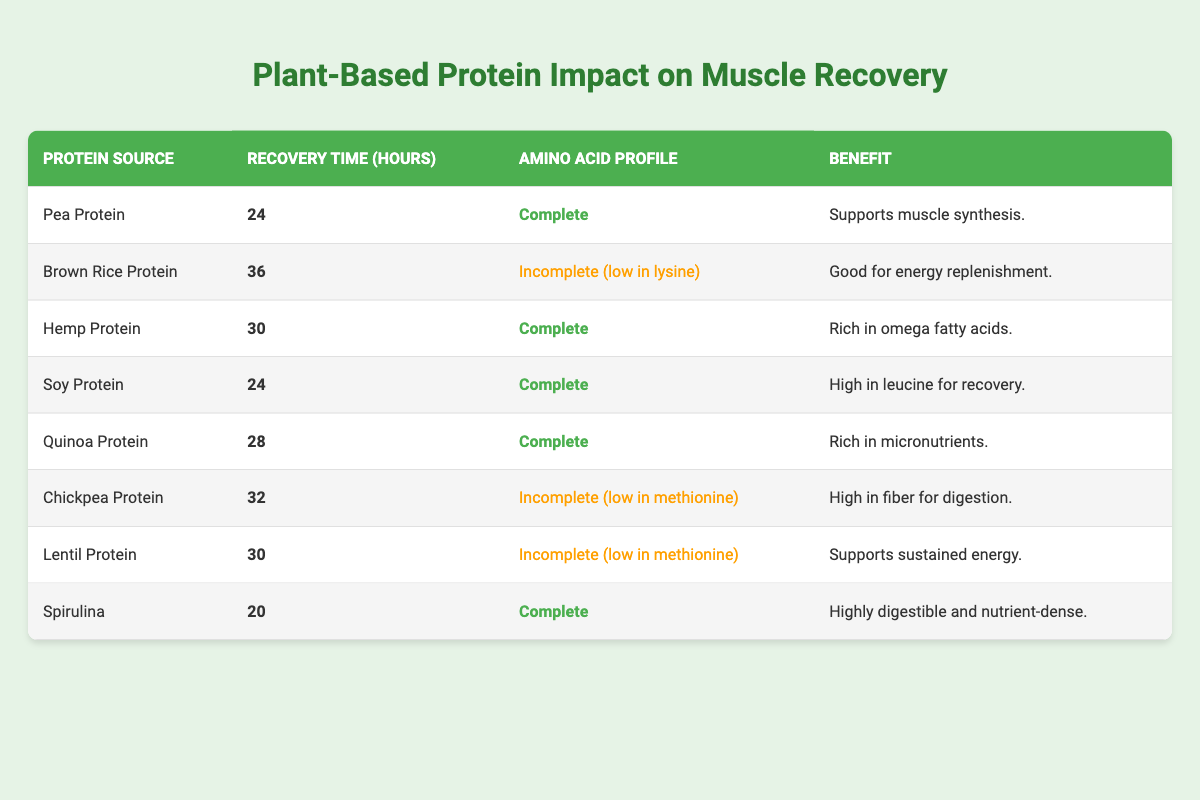What is the muscle recovery time for Pea Protein? The table shows that Pea Protein has a muscle recovery time of 24 hours.
Answer: 24 hours Which plant-based protein source has the highest muscle recovery time? The table lists Brown Rice Protein as having the highest muscle recovery time of 36 hours compared to the other sources.
Answer: Brown Rice Protein Is Spirulina's amino acid profile complete? Yes, according to the table, Spirulina has a complete amino acid profile.
Answer: Yes How many protein sources have a recovery time of 30 hours or more? The sources with 30 hours or more are Brown Rice Protein (36), Chickpea Protein (32), and Lentil Protein (30). Thus, there are 3 sources.
Answer: 3 What is the average muscle recovery time of all listed plant-based protein sources? Adding the recovery times: 24 + 36 + 30 + 24 + 28 + 32 + 30 + 20 =  224. There are 8 sources, so the average is 224/8 = 28 hours.
Answer: 28 hours Does any protein source have a muscle recovery time less than 25 hours? Yes, Pea Protein (24) and Spirulina (20) both have recovery times less than 25 hours.
Answer: Yes Which protein sources have an incomplete amino acid profile? From the table, the protein sources with incomplete profiles are Brown Rice Protein, Chickpea Protein, and Lentil Protein.
Answer: Brown Rice Protein, Chickpea Protein, Lentil Protein If you combine Pea and Soy Protein, what would be the total muscle recovery time? The recovery times for Pea and Soy are 24 hours and 24 hours. Adding them together gives 24 + 24 = 48 hours.
Answer: 48 hours Which plant-based protein benefits from being high in leucine? The table indicates that Soy Protein is high in leucine for recovery.
Answer: Soy Protein 